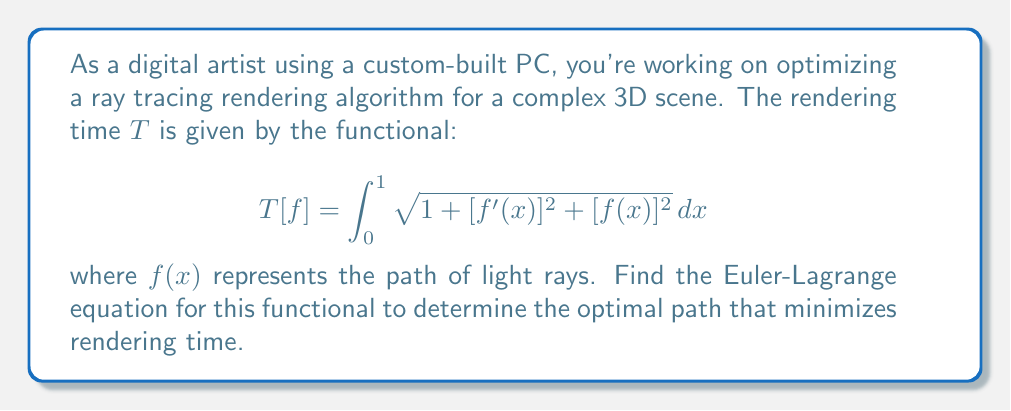Provide a solution to this math problem. To solve this problem, we'll use the calculus of variations and derive the Euler-Lagrange equation. The steps are as follows:

1) First, identify the integrand function $F(x, f, f')$:
   $$F(x, f, f') = \sqrt{1 + [f'(x)]^2 + [f(x)]^2}$$

2) The Euler-Lagrange equation is given by:
   $$\frac{\partial F}{\partial f} - \frac{d}{dx}\left(\frac{\partial F}{\partial f'}\right) = 0$$

3) Calculate $\frac{\partial F}{\partial f}$:
   $$\frac{\partial F}{\partial f} = \frac{f}{\sqrt{1 + [f']^2 + f^2}}$$

4) Calculate $\frac{\partial F}{\partial f'}$:
   $$\frac{\partial F}{\partial f'} = \frac{f'}{\sqrt{1 + [f']^2 + f^2}}$$

5) Calculate $\frac{d}{dx}\left(\frac{\partial F}{\partial f'}\right)$:
   $$\frac{d}{dx}\left(\frac{f'}{\sqrt{1 + [f']^2 + f^2}}\right) = \frac{f''(1 + [f']^2 + f^2) - f'(f'f'' + ff')}{(1 + [f']^2 + f^2)^{3/2}}$$

6) Substitute these results into the Euler-Lagrange equation:
   $$\frac{f}{\sqrt{1 + [f']^2 + f^2}} - \frac{f''(1 + [f']^2 + f^2) - f'(f'f'' + ff')}{(1 + [f']^2 + f^2)^{3/2}} = 0$$

7) Simplify:
   $$f(1 + [f']^2 + f^2) - f''(1 + [f']^2 + f^2) + f'(f'f'' + ff') = 0$$
   $$f + f[f']^2 + f^3 - f'' - f''[f']^2 - f''f^2 + [f']^2f'' + ff'f' = 0$$
   $$f + f[f']^2 + f^3 - f'' - f''f^2 + ff'f' = 0$$

This is the Euler-Lagrange equation for the given functional.
Answer: The Euler-Lagrange equation for the optimal path that minimizes rendering time is:

$$f + f[f']^2 + f^3 - f'' - f''f^2 + ff'f' = 0$$ 